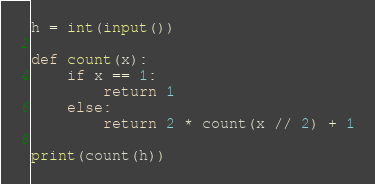<code> <loc_0><loc_0><loc_500><loc_500><_Python_>h = int(input())

def count(x):
    if x == 1:
        return 1
    else:
        return 2 * count(x // 2) + 1

print(count(h))</code> 